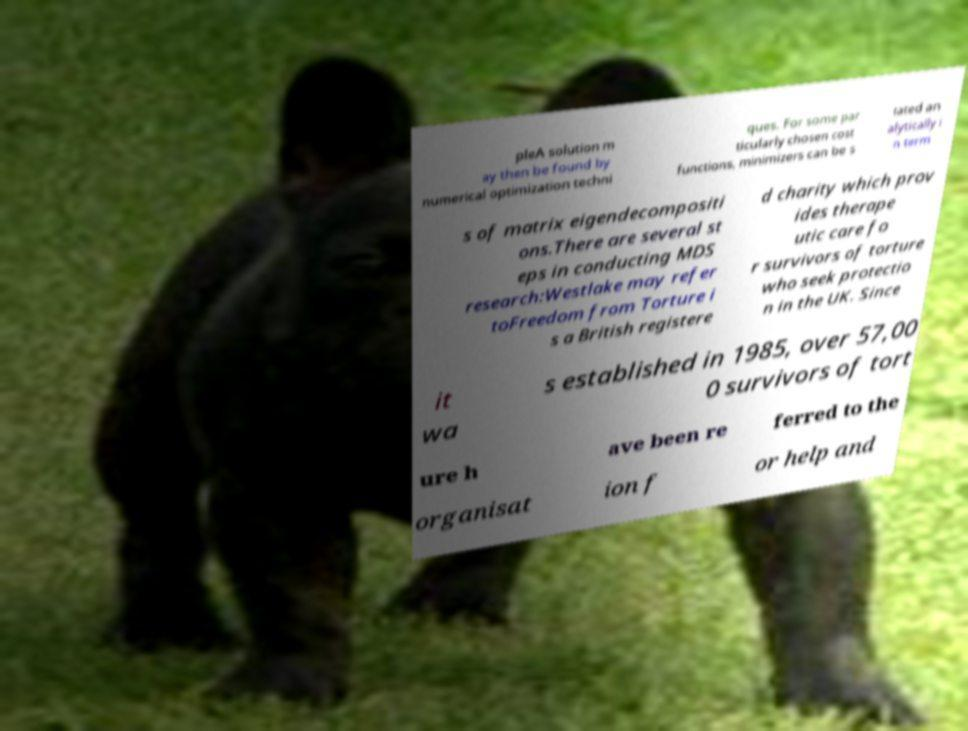There's text embedded in this image that I need extracted. Can you transcribe it verbatim? pleA solution m ay then be found by numerical optimization techni ques. For some par ticularly chosen cost functions, minimizers can be s tated an alytically i n term s of matrix eigendecompositi ons.There are several st eps in conducting MDS research:Westlake may refer toFreedom from Torture i s a British registere d charity which prov ides therape utic care fo r survivors of torture who seek protectio n in the UK. Since it wa s established in 1985, over 57,00 0 survivors of tort ure h ave been re ferred to the organisat ion f or help and 